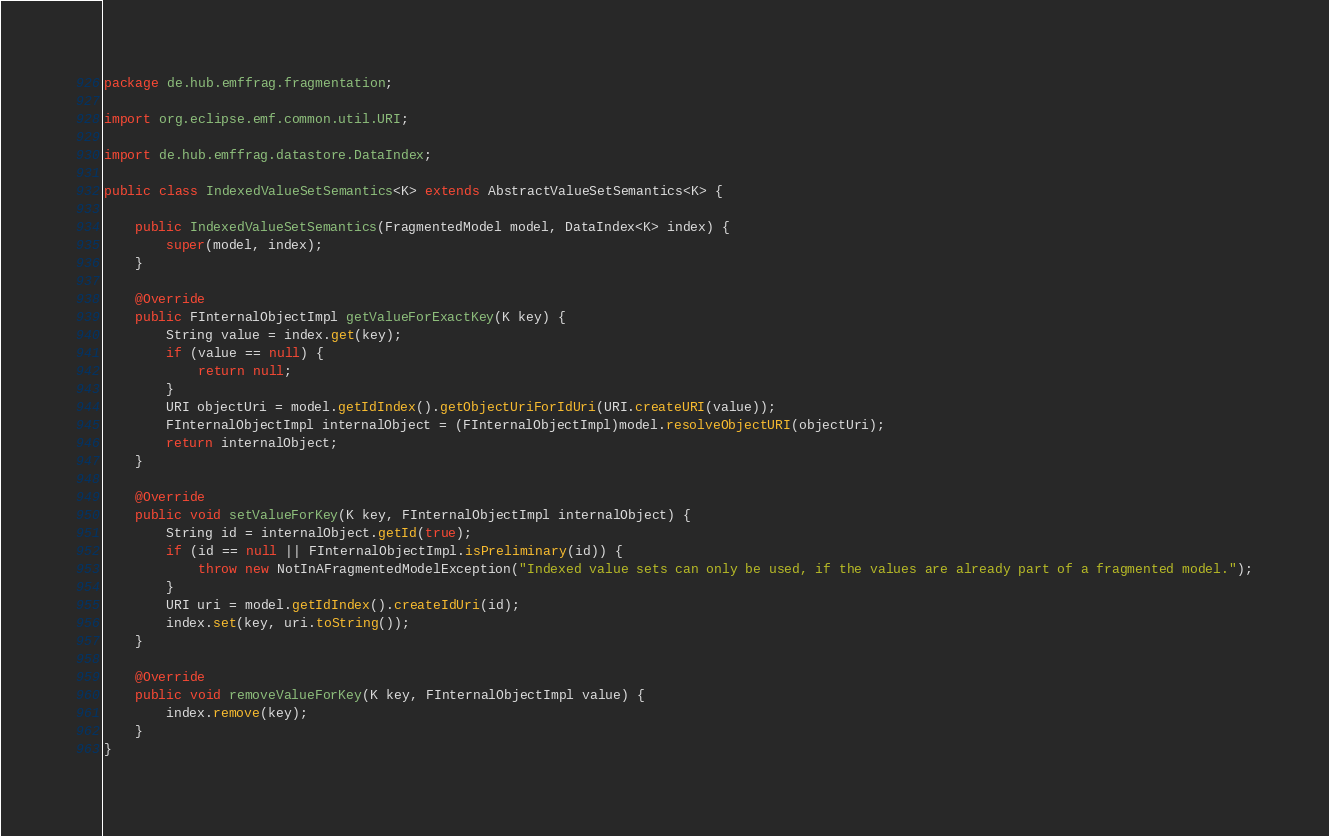Convert code to text. <code><loc_0><loc_0><loc_500><loc_500><_Java_>package de.hub.emffrag.fragmentation;

import org.eclipse.emf.common.util.URI;

import de.hub.emffrag.datastore.DataIndex;

public class IndexedValueSetSemantics<K> extends AbstractValueSetSemantics<K> {

	public IndexedValueSetSemantics(FragmentedModel model, DataIndex<K> index) {
		super(model, index);
	}

	@Override
	public FInternalObjectImpl getValueForExactKey(K key) {
		String value = index.get(key);
		if (value == null) {
			return null;
		}
		URI objectUri = model.getIdIndex().getObjectUriForIdUri(URI.createURI(value));
		FInternalObjectImpl internalObject = (FInternalObjectImpl)model.resolveObjectURI(objectUri);
		return internalObject;
	}
	
	@Override
	public void setValueForKey(K key, FInternalObjectImpl internalObject) {
		String id = internalObject.getId(true);
		if (id == null || FInternalObjectImpl.isPreliminary(id)) {
			throw new NotInAFragmentedModelException("Indexed value sets can only be used, if the values are already part of a fragmented model.");
		}
		URI uri = model.getIdIndex().createIdUri(id);
		index.set(key, uri.toString());
	}
	
	@Override
	public void removeValueForKey(K key, FInternalObjectImpl value) {
		index.remove(key);
	}
}
</code> 